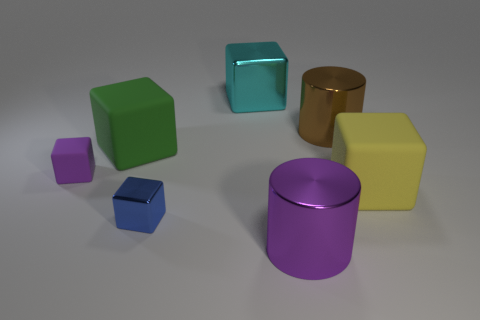The tiny metal thing has what color? Given the varied colors of the objects in the image, if we assume the question refers to the smallest object, there appears to be no 'tiny metal thing' within the image. However, if we consider the smallest cube, it appears to be purple, not blue. 